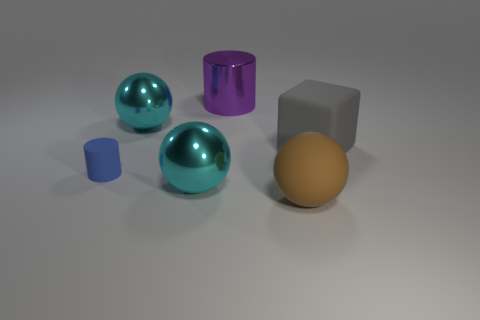Add 2 brown blocks. How many objects exist? 8 Subtract all cylinders. How many objects are left? 4 Subtract all large purple cylinders. Subtract all tiny brown metal balls. How many objects are left? 5 Add 2 large cylinders. How many large cylinders are left? 3 Add 4 tiny red matte spheres. How many tiny red matte spheres exist? 4 Subtract 1 brown balls. How many objects are left? 5 